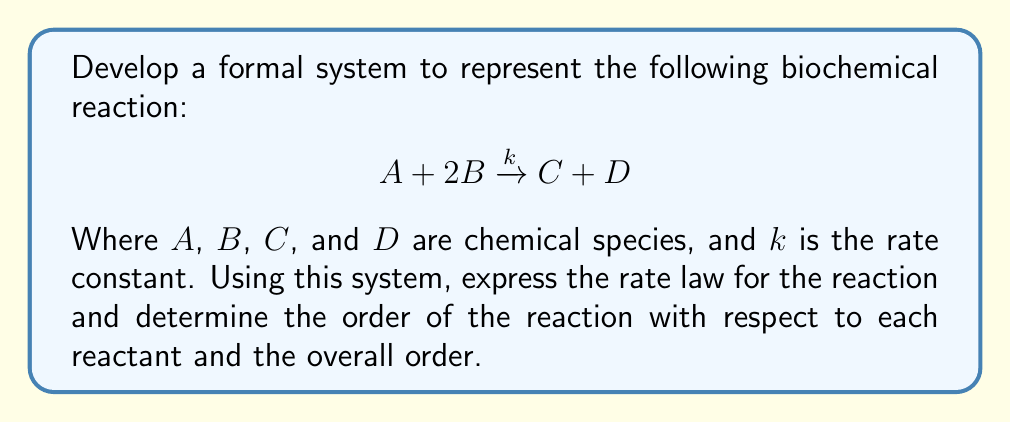Could you help me with this problem? To develop a formal system for representing and reasoning about biochemical reaction kinetics, we can use the following steps:

1. Representation of chemical species:
   Let $[X]$ denote the concentration of species $X$ in mol/L.

2. Rate law formulation:
   The rate of the reaction is proportional to the product of the concentrations of the reactants, each raised to the power of its stoichiometric coefficient. For this reaction:

   $$\text{Rate} = k[A]^a[B]^b$$

   Where $a$ and $b$ are the reaction orders with respect to $A$ and $B$, respectively.

3. Determining reaction orders:
   The reaction order for each species is typically equal to its stoichiometric coefficient in the balanced equation. In this case:
   
   $a = 1$ (coefficient of $A$ is 1)
   $b = 2$ (coefficient of $B$ is 2)

4. Expressing the rate law:
   Substituting the values of $a$ and $b$:

   $$\text{Rate} = k[A]^1[B]^2 = k[A][B]^2$$

5. Overall reaction order:
   The overall order of the reaction is the sum of the individual orders:
   
   Overall order $= a + b = 1 + 2 = 3$

This formal system allows us to represent the reaction kinetics and reason about the rate law and reaction orders.
Answer: Rate law: $$\text{Rate} = k[A][B]^2$$
Order with respect to $A$: 1
Order with respect to $B$: 2
Overall reaction order: 3 